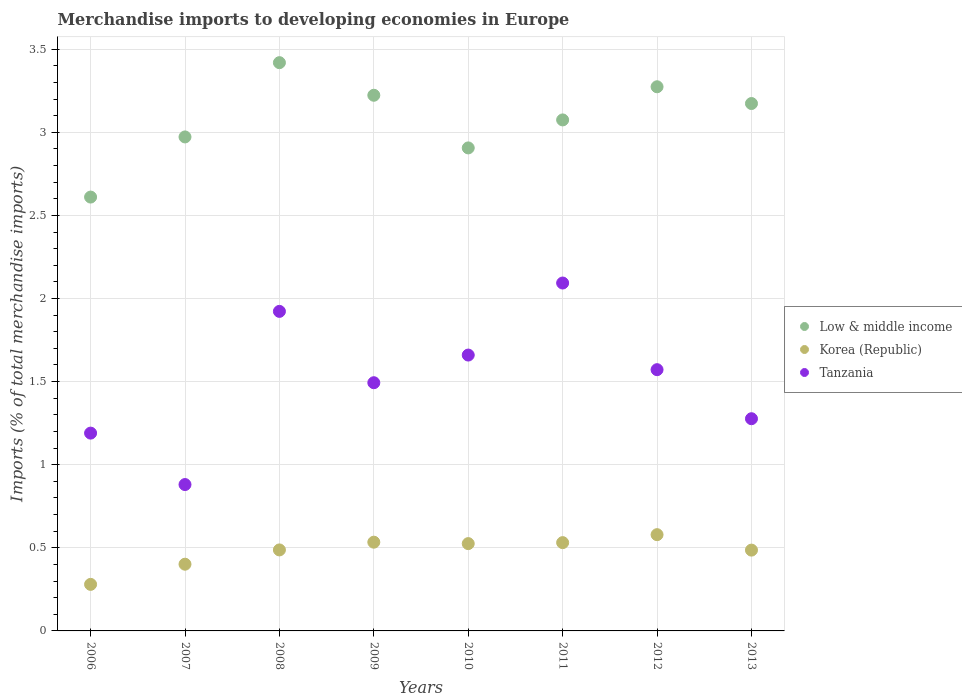How many different coloured dotlines are there?
Provide a short and direct response. 3. Is the number of dotlines equal to the number of legend labels?
Keep it short and to the point. Yes. What is the percentage total merchandise imports in Korea (Republic) in 2007?
Ensure brevity in your answer.  0.4. Across all years, what is the maximum percentage total merchandise imports in Korea (Republic)?
Offer a terse response. 0.58. Across all years, what is the minimum percentage total merchandise imports in Korea (Republic)?
Keep it short and to the point. 0.28. In which year was the percentage total merchandise imports in Low & middle income minimum?
Keep it short and to the point. 2006. What is the total percentage total merchandise imports in Low & middle income in the graph?
Offer a very short reply. 24.65. What is the difference between the percentage total merchandise imports in Tanzania in 2006 and that in 2010?
Ensure brevity in your answer.  -0.47. What is the difference between the percentage total merchandise imports in Tanzania in 2006 and the percentage total merchandise imports in Low & middle income in 2010?
Your answer should be compact. -1.72. What is the average percentage total merchandise imports in Low & middle income per year?
Your response must be concise. 3.08. In the year 2007, what is the difference between the percentage total merchandise imports in Tanzania and percentage total merchandise imports in Korea (Republic)?
Your response must be concise. 0.48. What is the ratio of the percentage total merchandise imports in Tanzania in 2007 to that in 2009?
Provide a succinct answer. 0.59. What is the difference between the highest and the second highest percentage total merchandise imports in Tanzania?
Make the answer very short. 0.17. What is the difference between the highest and the lowest percentage total merchandise imports in Tanzania?
Make the answer very short. 1.21. In how many years, is the percentage total merchandise imports in Tanzania greater than the average percentage total merchandise imports in Tanzania taken over all years?
Make the answer very short. 4. Does the percentage total merchandise imports in Korea (Republic) monotonically increase over the years?
Ensure brevity in your answer.  No. Is the percentage total merchandise imports in Low & middle income strictly greater than the percentage total merchandise imports in Tanzania over the years?
Your response must be concise. Yes. Is the percentage total merchandise imports in Low & middle income strictly less than the percentage total merchandise imports in Korea (Republic) over the years?
Offer a very short reply. No. How many dotlines are there?
Your answer should be compact. 3. How many years are there in the graph?
Provide a short and direct response. 8. Are the values on the major ticks of Y-axis written in scientific E-notation?
Keep it short and to the point. No. Does the graph contain grids?
Offer a terse response. Yes. Where does the legend appear in the graph?
Give a very brief answer. Center right. How many legend labels are there?
Ensure brevity in your answer.  3. How are the legend labels stacked?
Your answer should be compact. Vertical. What is the title of the graph?
Offer a very short reply. Merchandise imports to developing economies in Europe. Does "High income" appear as one of the legend labels in the graph?
Provide a short and direct response. No. What is the label or title of the Y-axis?
Make the answer very short. Imports (% of total merchandise imports). What is the Imports (% of total merchandise imports) of Low & middle income in 2006?
Offer a very short reply. 2.61. What is the Imports (% of total merchandise imports) of Korea (Republic) in 2006?
Your answer should be compact. 0.28. What is the Imports (% of total merchandise imports) of Tanzania in 2006?
Offer a terse response. 1.19. What is the Imports (% of total merchandise imports) of Low & middle income in 2007?
Keep it short and to the point. 2.97. What is the Imports (% of total merchandise imports) in Korea (Republic) in 2007?
Make the answer very short. 0.4. What is the Imports (% of total merchandise imports) of Tanzania in 2007?
Your answer should be very brief. 0.88. What is the Imports (% of total merchandise imports) in Low & middle income in 2008?
Your answer should be very brief. 3.42. What is the Imports (% of total merchandise imports) of Korea (Republic) in 2008?
Your answer should be very brief. 0.49. What is the Imports (% of total merchandise imports) of Tanzania in 2008?
Your answer should be very brief. 1.92. What is the Imports (% of total merchandise imports) in Low & middle income in 2009?
Provide a succinct answer. 3.22. What is the Imports (% of total merchandise imports) in Korea (Republic) in 2009?
Keep it short and to the point. 0.53. What is the Imports (% of total merchandise imports) in Tanzania in 2009?
Ensure brevity in your answer.  1.49. What is the Imports (% of total merchandise imports) of Low & middle income in 2010?
Make the answer very short. 2.91. What is the Imports (% of total merchandise imports) of Korea (Republic) in 2010?
Offer a very short reply. 0.53. What is the Imports (% of total merchandise imports) of Tanzania in 2010?
Offer a very short reply. 1.66. What is the Imports (% of total merchandise imports) of Low & middle income in 2011?
Give a very brief answer. 3.07. What is the Imports (% of total merchandise imports) in Korea (Republic) in 2011?
Offer a terse response. 0.53. What is the Imports (% of total merchandise imports) of Tanzania in 2011?
Keep it short and to the point. 2.09. What is the Imports (% of total merchandise imports) in Low & middle income in 2012?
Keep it short and to the point. 3.27. What is the Imports (% of total merchandise imports) of Korea (Republic) in 2012?
Your response must be concise. 0.58. What is the Imports (% of total merchandise imports) of Tanzania in 2012?
Provide a succinct answer. 1.57. What is the Imports (% of total merchandise imports) of Low & middle income in 2013?
Make the answer very short. 3.17. What is the Imports (% of total merchandise imports) of Korea (Republic) in 2013?
Ensure brevity in your answer.  0.49. What is the Imports (% of total merchandise imports) in Tanzania in 2013?
Make the answer very short. 1.28. Across all years, what is the maximum Imports (% of total merchandise imports) of Low & middle income?
Make the answer very short. 3.42. Across all years, what is the maximum Imports (% of total merchandise imports) of Korea (Republic)?
Offer a terse response. 0.58. Across all years, what is the maximum Imports (% of total merchandise imports) in Tanzania?
Give a very brief answer. 2.09. Across all years, what is the minimum Imports (% of total merchandise imports) in Low & middle income?
Your response must be concise. 2.61. Across all years, what is the minimum Imports (% of total merchandise imports) of Korea (Republic)?
Your answer should be very brief. 0.28. Across all years, what is the minimum Imports (% of total merchandise imports) of Tanzania?
Make the answer very short. 0.88. What is the total Imports (% of total merchandise imports) of Low & middle income in the graph?
Your answer should be very brief. 24.65. What is the total Imports (% of total merchandise imports) in Korea (Republic) in the graph?
Offer a very short reply. 3.82. What is the total Imports (% of total merchandise imports) of Tanzania in the graph?
Offer a terse response. 12.09. What is the difference between the Imports (% of total merchandise imports) in Low & middle income in 2006 and that in 2007?
Provide a short and direct response. -0.36. What is the difference between the Imports (% of total merchandise imports) of Korea (Republic) in 2006 and that in 2007?
Your answer should be very brief. -0.12. What is the difference between the Imports (% of total merchandise imports) in Tanzania in 2006 and that in 2007?
Your answer should be compact. 0.31. What is the difference between the Imports (% of total merchandise imports) in Low & middle income in 2006 and that in 2008?
Give a very brief answer. -0.81. What is the difference between the Imports (% of total merchandise imports) of Korea (Republic) in 2006 and that in 2008?
Provide a short and direct response. -0.21. What is the difference between the Imports (% of total merchandise imports) of Tanzania in 2006 and that in 2008?
Provide a short and direct response. -0.73. What is the difference between the Imports (% of total merchandise imports) of Low & middle income in 2006 and that in 2009?
Offer a very short reply. -0.61. What is the difference between the Imports (% of total merchandise imports) of Korea (Republic) in 2006 and that in 2009?
Your answer should be very brief. -0.25. What is the difference between the Imports (% of total merchandise imports) of Tanzania in 2006 and that in 2009?
Your response must be concise. -0.3. What is the difference between the Imports (% of total merchandise imports) in Low & middle income in 2006 and that in 2010?
Ensure brevity in your answer.  -0.3. What is the difference between the Imports (% of total merchandise imports) in Korea (Republic) in 2006 and that in 2010?
Offer a very short reply. -0.25. What is the difference between the Imports (% of total merchandise imports) of Tanzania in 2006 and that in 2010?
Give a very brief answer. -0.47. What is the difference between the Imports (% of total merchandise imports) in Low & middle income in 2006 and that in 2011?
Ensure brevity in your answer.  -0.46. What is the difference between the Imports (% of total merchandise imports) in Korea (Republic) in 2006 and that in 2011?
Offer a very short reply. -0.25. What is the difference between the Imports (% of total merchandise imports) in Tanzania in 2006 and that in 2011?
Provide a short and direct response. -0.9. What is the difference between the Imports (% of total merchandise imports) of Low & middle income in 2006 and that in 2012?
Provide a succinct answer. -0.66. What is the difference between the Imports (% of total merchandise imports) of Korea (Republic) in 2006 and that in 2012?
Your answer should be compact. -0.3. What is the difference between the Imports (% of total merchandise imports) in Tanzania in 2006 and that in 2012?
Your answer should be very brief. -0.38. What is the difference between the Imports (% of total merchandise imports) of Low & middle income in 2006 and that in 2013?
Provide a succinct answer. -0.56. What is the difference between the Imports (% of total merchandise imports) in Korea (Republic) in 2006 and that in 2013?
Offer a very short reply. -0.21. What is the difference between the Imports (% of total merchandise imports) of Tanzania in 2006 and that in 2013?
Your answer should be very brief. -0.09. What is the difference between the Imports (% of total merchandise imports) of Low & middle income in 2007 and that in 2008?
Offer a very short reply. -0.45. What is the difference between the Imports (% of total merchandise imports) of Korea (Republic) in 2007 and that in 2008?
Provide a succinct answer. -0.09. What is the difference between the Imports (% of total merchandise imports) of Tanzania in 2007 and that in 2008?
Your response must be concise. -1.04. What is the difference between the Imports (% of total merchandise imports) in Low & middle income in 2007 and that in 2009?
Ensure brevity in your answer.  -0.25. What is the difference between the Imports (% of total merchandise imports) in Korea (Republic) in 2007 and that in 2009?
Give a very brief answer. -0.13. What is the difference between the Imports (% of total merchandise imports) in Tanzania in 2007 and that in 2009?
Offer a terse response. -0.61. What is the difference between the Imports (% of total merchandise imports) in Low & middle income in 2007 and that in 2010?
Your response must be concise. 0.07. What is the difference between the Imports (% of total merchandise imports) in Korea (Republic) in 2007 and that in 2010?
Ensure brevity in your answer.  -0.12. What is the difference between the Imports (% of total merchandise imports) in Tanzania in 2007 and that in 2010?
Offer a terse response. -0.78. What is the difference between the Imports (% of total merchandise imports) in Low & middle income in 2007 and that in 2011?
Your answer should be very brief. -0.1. What is the difference between the Imports (% of total merchandise imports) of Korea (Republic) in 2007 and that in 2011?
Offer a very short reply. -0.13. What is the difference between the Imports (% of total merchandise imports) in Tanzania in 2007 and that in 2011?
Offer a terse response. -1.21. What is the difference between the Imports (% of total merchandise imports) in Low & middle income in 2007 and that in 2012?
Ensure brevity in your answer.  -0.3. What is the difference between the Imports (% of total merchandise imports) in Korea (Republic) in 2007 and that in 2012?
Offer a very short reply. -0.18. What is the difference between the Imports (% of total merchandise imports) of Tanzania in 2007 and that in 2012?
Offer a terse response. -0.69. What is the difference between the Imports (% of total merchandise imports) of Low & middle income in 2007 and that in 2013?
Keep it short and to the point. -0.2. What is the difference between the Imports (% of total merchandise imports) of Korea (Republic) in 2007 and that in 2013?
Make the answer very short. -0.08. What is the difference between the Imports (% of total merchandise imports) of Tanzania in 2007 and that in 2013?
Your answer should be very brief. -0.4. What is the difference between the Imports (% of total merchandise imports) of Low & middle income in 2008 and that in 2009?
Provide a succinct answer. 0.2. What is the difference between the Imports (% of total merchandise imports) of Korea (Republic) in 2008 and that in 2009?
Provide a short and direct response. -0.05. What is the difference between the Imports (% of total merchandise imports) in Tanzania in 2008 and that in 2009?
Provide a short and direct response. 0.43. What is the difference between the Imports (% of total merchandise imports) of Low & middle income in 2008 and that in 2010?
Your response must be concise. 0.51. What is the difference between the Imports (% of total merchandise imports) of Korea (Republic) in 2008 and that in 2010?
Keep it short and to the point. -0.04. What is the difference between the Imports (% of total merchandise imports) in Tanzania in 2008 and that in 2010?
Your response must be concise. 0.26. What is the difference between the Imports (% of total merchandise imports) in Low & middle income in 2008 and that in 2011?
Your response must be concise. 0.34. What is the difference between the Imports (% of total merchandise imports) of Korea (Republic) in 2008 and that in 2011?
Keep it short and to the point. -0.04. What is the difference between the Imports (% of total merchandise imports) in Tanzania in 2008 and that in 2011?
Your response must be concise. -0.17. What is the difference between the Imports (% of total merchandise imports) in Low & middle income in 2008 and that in 2012?
Your answer should be compact. 0.14. What is the difference between the Imports (% of total merchandise imports) in Korea (Republic) in 2008 and that in 2012?
Your response must be concise. -0.09. What is the difference between the Imports (% of total merchandise imports) in Tanzania in 2008 and that in 2012?
Offer a very short reply. 0.35. What is the difference between the Imports (% of total merchandise imports) in Low & middle income in 2008 and that in 2013?
Provide a short and direct response. 0.25. What is the difference between the Imports (% of total merchandise imports) of Korea (Republic) in 2008 and that in 2013?
Your response must be concise. 0. What is the difference between the Imports (% of total merchandise imports) in Tanzania in 2008 and that in 2013?
Your answer should be very brief. 0.65. What is the difference between the Imports (% of total merchandise imports) in Low & middle income in 2009 and that in 2010?
Offer a very short reply. 0.32. What is the difference between the Imports (% of total merchandise imports) in Korea (Republic) in 2009 and that in 2010?
Your answer should be very brief. 0.01. What is the difference between the Imports (% of total merchandise imports) in Tanzania in 2009 and that in 2010?
Keep it short and to the point. -0.17. What is the difference between the Imports (% of total merchandise imports) in Low & middle income in 2009 and that in 2011?
Your response must be concise. 0.15. What is the difference between the Imports (% of total merchandise imports) in Korea (Republic) in 2009 and that in 2011?
Make the answer very short. 0. What is the difference between the Imports (% of total merchandise imports) in Tanzania in 2009 and that in 2011?
Give a very brief answer. -0.6. What is the difference between the Imports (% of total merchandise imports) in Low & middle income in 2009 and that in 2012?
Keep it short and to the point. -0.05. What is the difference between the Imports (% of total merchandise imports) in Korea (Republic) in 2009 and that in 2012?
Give a very brief answer. -0.05. What is the difference between the Imports (% of total merchandise imports) of Tanzania in 2009 and that in 2012?
Keep it short and to the point. -0.08. What is the difference between the Imports (% of total merchandise imports) of Low & middle income in 2009 and that in 2013?
Your answer should be very brief. 0.05. What is the difference between the Imports (% of total merchandise imports) of Korea (Republic) in 2009 and that in 2013?
Ensure brevity in your answer.  0.05. What is the difference between the Imports (% of total merchandise imports) of Tanzania in 2009 and that in 2013?
Keep it short and to the point. 0.22. What is the difference between the Imports (% of total merchandise imports) in Low & middle income in 2010 and that in 2011?
Keep it short and to the point. -0.17. What is the difference between the Imports (% of total merchandise imports) in Korea (Republic) in 2010 and that in 2011?
Ensure brevity in your answer.  -0.01. What is the difference between the Imports (% of total merchandise imports) of Tanzania in 2010 and that in 2011?
Keep it short and to the point. -0.43. What is the difference between the Imports (% of total merchandise imports) of Low & middle income in 2010 and that in 2012?
Provide a succinct answer. -0.37. What is the difference between the Imports (% of total merchandise imports) of Korea (Republic) in 2010 and that in 2012?
Offer a terse response. -0.05. What is the difference between the Imports (% of total merchandise imports) in Tanzania in 2010 and that in 2012?
Keep it short and to the point. 0.09. What is the difference between the Imports (% of total merchandise imports) in Low & middle income in 2010 and that in 2013?
Provide a short and direct response. -0.27. What is the difference between the Imports (% of total merchandise imports) in Korea (Republic) in 2010 and that in 2013?
Your answer should be very brief. 0.04. What is the difference between the Imports (% of total merchandise imports) of Tanzania in 2010 and that in 2013?
Your answer should be compact. 0.38. What is the difference between the Imports (% of total merchandise imports) of Low & middle income in 2011 and that in 2012?
Give a very brief answer. -0.2. What is the difference between the Imports (% of total merchandise imports) in Korea (Republic) in 2011 and that in 2012?
Make the answer very short. -0.05. What is the difference between the Imports (% of total merchandise imports) in Tanzania in 2011 and that in 2012?
Offer a terse response. 0.52. What is the difference between the Imports (% of total merchandise imports) of Low & middle income in 2011 and that in 2013?
Make the answer very short. -0.1. What is the difference between the Imports (% of total merchandise imports) of Korea (Republic) in 2011 and that in 2013?
Your answer should be compact. 0.04. What is the difference between the Imports (% of total merchandise imports) in Tanzania in 2011 and that in 2013?
Your answer should be compact. 0.82. What is the difference between the Imports (% of total merchandise imports) of Low & middle income in 2012 and that in 2013?
Your response must be concise. 0.1. What is the difference between the Imports (% of total merchandise imports) of Korea (Republic) in 2012 and that in 2013?
Your answer should be very brief. 0.09. What is the difference between the Imports (% of total merchandise imports) in Tanzania in 2012 and that in 2013?
Your response must be concise. 0.3. What is the difference between the Imports (% of total merchandise imports) in Low & middle income in 2006 and the Imports (% of total merchandise imports) in Korea (Republic) in 2007?
Offer a terse response. 2.21. What is the difference between the Imports (% of total merchandise imports) of Low & middle income in 2006 and the Imports (% of total merchandise imports) of Tanzania in 2007?
Provide a short and direct response. 1.73. What is the difference between the Imports (% of total merchandise imports) in Korea (Republic) in 2006 and the Imports (% of total merchandise imports) in Tanzania in 2007?
Your answer should be compact. -0.6. What is the difference between the Imports (% of total merchandise imports) of Low & middle income in 2006 and the Imports (% of total merchandise imports) of Korea (Republic) in 2008?
Provide a succinct answer. 2.12. What is the difference between the Imports (% of total merchandise imports) of Low & middle income in 2006 and the Imports (% of total merchandise imports) of Tanzania in 2008?
Give a very brief answer. 0.69. What is the difference between the Imports (% of total merchandise imports) in Korea (Republic) in 2006 and the Imports (% of total merchandise imports) in Tanzania in 2008?
Your response must be concise. -1.64. What is the difference between the Imports (% of total merchandise imports) in Low & middle income in 2006 and the Imports (% of total merchandise imports) in Korea (Republic) in 2009?
Keep it short and to the point. 2.08. What is the difference between the Imports (% of total merchandise imports) of Low & middle income in 2006 and the Imports (% of total merchandise imports) of Tanzania in 2009?
Offer a terse response. 1.12. What is the difference between the Imports (% of total merchandise imports) of Korea (Republic) in 2006 and the Imports (% of total merchandise imports) of Tanzania in 2009?
Provide a short and direct response. -1.21. What is the difference between the Imports (% of total merchandise imports) in Low & middle income in 2006 and the Imports (% of total merchandise imports) in Korea (Republic) in 2010?
Give a very brief answer. 2.08. What is the difference between the Imports (% of total merchandise imports) of Low & middle income in 2006 and the Imports (% of total merchandise imports) of Tanzania in 2010?
Keep it short and to the point. 0.95. What is the difference between the Imports (% of total merchandise imports) in Korea (Republic) in 2006 and the Imports (% of total merchandise imports) in Tanzania in 2010?
Your answer should be very brief. -1.38. What is the difference between the Imports (% of total merchandise imports) of Low & middle income in 2006 and the Imports (% of total merchandise imports) of Korea (Republic) in 2011?
Your answer should be compact. 2.08. What is the difference between the Imports (% of total merchandise imports) in Low & middle income in 2006 and the Imports (% of total merchandise imports) in Tanzania in 2011?
Keep it short and to the point. 0.52. What is the difference between the Imports (% of total merchandise imports) of Korea (Republic) in 2006 and the Imports (% of total merchandise imports) of Tanzania in 2011?
Provide a short and direct response. -1.81. What is the difference between the Imports (% of total merchandise imports) of Low & middle income in 2006 and the Imports (% of total merchandise imports) of Korea (Republic) in 2012?
Offer a very short reply. 2.03. What is the difference between the Imports (% of total merchandise imports) in Low & middle income in 2006 and the Imports (% of total merchandise imports) in Tanzania in 2012?
Keep it short and to the point. 1.04. What is the difference between the Imports (% of total merchandise imports) in Korea (Republic) in 2006 and the Imports (% of total merchandise imports) in Tanzania in 2012?
Your answer should be compact. -1.29. What is the difference between the Imports (% of total merchandise imports) in Low & middle income in 2006 and the Imports (% of total merchandise imports) in Korea (Republic) in 2013?
Offer a very short reply. 2.12. What is the difference between the Imports (% of total merchandise imports) of Low & middle income in 2006 and the Imports (% of total merchandise imports) of Tanzania in 2013?
Make the answer very short. 1.33. What is the difference between the Imports (% of total merchandise imports) of Korea (Republic) in 2006 and the Imports (% of total merchandise imports) of Tanzania in 2013?
Offer a very short reply. -1. What is the difference between the Imports (% of total merchandise imports) of Low & middle income in 2007 and the Imports (% of total merchandise imports) of Korea (Republic) in 2008?
Make the answer very short. 2.48. What is the difference between the Imports (% of total merchandise imports) of Low & middle income in 2007 and the Imports (% of total merchandise imports) of Tanzania in 2008?
Keep it short and to the point. 1.05. What is the difference between the Imports (% of total merchandise imports) of Korea (Republic) in 2007 and the Imports (% of total merchandise imports) of Tanzania in 2008?
Offer a very short reply. -1.52. What is the difference between the Imports (% of total merchandise imports) of Low & middle income in 2007 and the Imports (% of total merchandise imports) of Korea (Republic) in 2009?
Offer a terse response. 2.44. What is the difference between the Imports (% of total merchandise imports) in Low & middle income in 2007 and the Imports (% of total merchandise imports) in Tanzania in 2009?
Offer a very short reply. 1.48. What is the difference between the Imports (% of total merchandise imports) of Korea (Republic) in 2007 and the Imports (% of total merchandise imports) of Tanzania in 2009?
Your answer should be very brief. -1.09. What is the difference between the Imports (% of total merchandise imports) of Low & middle income in 2007 and the Imports (% of total merchandise imports) of Korea (Republic) in 2010?
Give a very brief answer. 2.45. What is the difference between the Imports (% of total merchandise imports) of Low & middle income in 2007 and the Imports (% of total merchandise imports) of Tanzania in 2010?
Keep it short and to the point. 1.31. What is the difference between the Imports (% of total merchandise imports) in Korea (Republic) in 2007 and the Imports (% of total merchandise imports) in Tanzania in 2010?
Offer a terse response. -1.26. What is the difference between the Imports (% of total merchandise imports) of Low & middle income in 2007 and the Imports (% of total merchandise imports) of Korea (Republic) in 2011?
Your response must be concise. 2.44. What is the difference between the Imports (% of total merchandise imports) of Low & middle income in 2007 and the Imports (% of total merchandise imports) of Tanzania in 2011?
Keep it short and to the point. 0.88. What is the difference between the Imports (% of total merchandise imports) in Korea (Republic) in 2007 and the Imports (% of total merchandise imports) in Tanzania in 2011?
Give a very brief answer. -1.69. What is the difference between the Imports (% of total merchandise imports) in Low & middle income in 2007 and the Imports (% of total merchandise imports) in Korea (Republic) in 2012?
Ensure brevity in your answer.  2.39. What is the difference between the Imports (% of total merchandise imports) of Low & middle income in 2007 and the Imports (% of total merchandise imports) of Tanzania in 2012?
Your answer should be very brief. 1.4. What is the difference between the Imports (% of total merchandise imports) of Korea (Republic) in 2007 and the Imports (% of total merchandise imports) of Tanzania in 2012?
Provide a short and direct response. -1.17. What is the difference between the Imports (% of total merchandise imports) of Low & middle income in 2007 and the Imports (% of total merchandise imports) of Korea (Republic) in 2013?
Offer a terse response. 2.49. What is the difference between the Imports (% of total merchandise imports) of Low & middle income in 2007 and the Imports (% of total merchandise imports) of Tanzania in 2013?
Ensure brevity in your answer.  1.7. What is the difference between the Imports (% of total merchandise imports) of Korea (Republic) in 2007 and the Imports (% of total merchandise imports) of Tanzania in 2013?
Give a very brief answer. -0.88. What is the difference between the Imports (% of total merchandise imports) of Low & middle income in 2008 and the Imports (% of total merchandise imports) of Korea (Republic) in 2009?
Your response must be concise. 2.88. What is the difference between the Imports (% of total merchandise imports) in Low & middle income in 2008 and the Imports (% of total merchandise imports) in Tanzania in 2009?
Give a very brief answer. 1.93. What is the difference between the Imports (% of total merchandise imports) of Korea (Republic) in 2008 and the Imports (% of total merchandise imports) of Tanzania in 2009?
Offer a very short reply. -1.01. What is the difference between the Imports (% of total merchandise imports) in Low & middle income in 2008 and the Imports (% of total merchandise imports) in Korea (Republic) in 2010?
Your answer should be compact. 2.89. What is the difference between the Imports (% of total merchandise imports) in Low & middle income in 2008 and the Imports (% of total merchandise imports) in Tanzania in 2010?
Your answer should be very brief. 1.76. What is the difference between the Imports (% of total merchandise imports) in Korea (Republic) in 2008 and the Imports (% of total merchandise imports) in Tanzania in 2010?
Ensure brevity in your answer.  -1.17. What is the difference between the Imports (% of total merchandise imports) in Low & middle income in 2008 and the Imports (% of total merchandise imports) in Korea (Republic) in 2011?
Your response must be concise. 2.89. What is the difference between the Imports (% of total merchandise imports) of Low & middle income in 2008 and the Imports (% of total merchandise imports) of Tanzania in 2011?
Give a very brief answer. 1.33. What is the difference between the Imports (% of total merchandise imports) of Korea (Republic) in 2008 and the Imports (% of total merchandise imports) of Tanzania in 2011?
Your response must be concise. -1.61. What is the difference between the Imports (% of total merchandise imports) of Low & middle income in 2008 and the Imports (% of total merchandise imports) of Korea (Republic) in 2012?
Provide a succinct answer. 2.84. What is the difference between the Imports (% of total merchandise imports) of Low & middle income in 2008 and the Imports (% of total merchandise imports) of Tanzania in 2012?
Provide a succinct answer. 1.85. What is the difference between the Imports (% of total merchandise imports) in Korea (Republic) in 2008 and the Imports (% of total merchandise imports) in Tanzania in 2012?
Provide a succinct answer. -1.08. What is the difference between the Imports (% of total merchandise imports) of Low & middle income in 2008 and the Imports (% of total merchandise imports) of Korea (Republic) in 2013?
Offer a terse response. 2.93. What is the difference between the Imports (% of total merchandise imports) in Low & middle income in 2008 and the Imports (% of total merchandise imports) in Tanzania in 2013?
Offer a terse response. 2.14. What is the difference between the Imports (% of total merchandise imports) of Korea (Republic) in 2008 and the Imports (% of total merchandise imports) of Tanzania in 2013?
Offer a very short reply. -0.79. What is the difference between the Imports (% of total merchandise imports) in Low & middle income in 2009 and the Imports (% of total merchandise imports) in Korea (Republic) in 2010?
Provide a short and direct response. 2.7. What is the difference between the Imports (% of total merchandise imports) in Low & middle income in 2009 and the Imports (% of total merchandise imports) in Tanzania in 2010?
Your response must be concise. 1.56. What is the difference between the Imports (% of total merchandise imports) of Korea (Republic) in 2009 and the Imports (% of total merchandise imports) of Tanzania in 2010?
Your answer should be very brief. -1.13. What is the difference between the Imports (% of total merchandise imports) of Low & middle income in 2009 and the Imports (% of total merchandise imports) of Korea (Republic) in 2011?
Offer a terse response. 2.69. What is the difference between the Imports (% of total merchandise imports) in Low & middle income in 2009 and the Imports (% of total merchandise imports) in Tanzania in 2011?
Ensure brevity in your answer.  1.13. What is the difference between the Imports (% of total merchandise imports) of Korea (Republic) in 2009 and the Imports (% of total merchandise imports) of Tanzania in 2011?
Make the answer very short. -1.56. What is the difference between the Imports (% of total merchandise imports) of Low & middle income in 2009 and the Imports (% of total merchandise imports) of Korea (Republic) in 2012?
Provide a succinct answer. 2.64. What is the difference between the Imports (% of total merchandise imports) of Low & middle income in 2009 and the Imports (% of total merchandise imports) of Tanzania in 2012?
Your answer should be compact. 1.65. What is the difference between the Imports (% of total merchandise imports) of Korea (Republic) in 2009 and the Imports (% of total merchandise imports) of Tanzania in 2012?
Provide a succinct answer. -1.04. What is the difference between the Imports (% of total merchandise imports) of Low & middle income in 2009 and the Imports (% of total merchandise imports) of Korea (Republic) in 2013?
Ensure brevity in your answer.  2.74. What is the difference between the Imports (% of total merchandise imports) in Low & middle income in 2009 and the Imports (% of total merchandise imports) in Tanzania in 2013?
Provide a short and direct response. 1.95. What is the difference between the Imports (% of total merchandise imports) of Korea (Republic) in 2009 and the Imports (% of total merchandise imports) of Tanzania in 2013?
Keep it short and to the point. -0.74. What is the difference between the Imports (% of total merchandise imports) of Low & middle income in 2010 and the Imports (% of total merchandise imports) of Korea (Republic) in 2011?
Ensure brevity in your answer.  2.37. What is the difference between the Imports (% of total merchandise imports) of Low & middle income in 2010 and the Imports (% of total merchandise imports) of Tanzania in 2011?
Your response must be concise. 0.81. What is the difference between the Imports (% of total merchandise imports) of Korea (Republic) in 2010 and the Imports (% of total merchandise imports) of Tanzania in 2011?
Your response must be concise. -1.57. What is the difference between the Imports (% of total merchandise imports) of Low & middle income in 2010 and the Imports (% of total merchandise imports) of Korea (Republic) in 2012?
Give a very brief answer. 2.33. What is the difference between the Imports (% of total merchandise imports) in Low & middle income in 2010 and the Imports (% of total merchandise imports) in Tanzania in 2012?
Ensure brevity in your answer.  1.33. What is the difference between the Imports (% of total merchandise imports) in Korea (Republic) in 2010 and the Imports (% of total merchandise imports) in Tanzania in 2012?
Make the answer very short. -1.05. What is the difference between the Imports (% of total merchandise imports) of Low & middle income in 2010 and the Imports (% of total merchandise imports) of Korea (Republic) in 2013?
Offer a very short reply. 2.42. What is the difference between the Imports (% of total merchandise imports) in Low & middle income in 2010 and the Imports (% of total merchandise imports) in Tanzania in 2013?
Keep it short and to the point. 1.63. What is the difference between the Imports (% of total merchandise imports) in Korea (Republic) in 2010 and the Imports (% of total merchandise imports) in Tanzania in 2013?
Provide a succinct answer. -0.75. What is the difference between the Imports (% of total merchandise imports) in Low & middle income in 2011 and the Imports (% of total merchandise imports) in Korea (Republic) in 2012?
Provide a short and direct response. 2.5. What is the difference between the Imports (% of total merchandise imports) in Low & middle income in 2011 and the Imports (% of total merchandise imports) in Tanzania in 2012?
Your answer should be very brief. 1.5. What is the difference between the Imports (% of total merchandise imports) in Korea (Republic) in 2011 and the Imports (% of total merchandise imports) in Tanzania in 2012?
Your response must be concise. -1.04. What is the difference between the Imports (% of total merchandise imports) in Low & middle income in 2011 and the Imports (% of total merchandise imports) in Korea (Republic) in 2013?
Keep it short and to the point. 2.59. What is the difference between the Imports (% of total merchandise imports) of Low & middle income in 2011 and the Imports (% of total merchandise imports) of Tanzania in 2013?
Your answer should be compact. 1.8. What is the difference between the Imports (% of total merchandise imports) of Korea (Republic) in 2011 and the Imports (% of total merchandise imports) of Tanzania in 2013?
Offer a terse response. -0.75. What is the difference between the Imports (% of total merchandise imports) of Low & middle income in 2012 and the Imports (% of total merchandise imports) of Korea (Republic) in 2013?
Offer a terse response. 2.79. What is the difference between the Imports (% of total merchandise imports) of Low & middle income in 2012 and the Imports (% of total merchandise imports) of Tanzania in 2013?
Ensure brevity in your answer.  2. What is the difference between the Imports (% of total merchandise imports) of Korea (Republic) in 2012 and the Imports (% of total merchandise imports) of Tanzania in 2013?
Keep it short and to the point. -0.7. What is the average Imports (% of total merchandise imports) in Low & middle income per year?
Make the answer very short. 3.08. What is the average Imports (% of total merchandise imports) of Korea (Republic) per year?
Ensure brevity in your answer.  0.48. What is the average Imports (% of total merchandise imports) in Tanzania per year?
Ensure brevity in your answer.  1.51. In the year 2006, what is the difference between the Imports (% of total merchandise imports) in Low & middle income and Imports (% of total merchandise imports) in Korea (Republic)?
Provide a succinct answer. 2.33. In the year 2006, what is the difference between the Imports (% of total merchandise imports) in Low & middle income and Imports (% of total merchandise imports) in Tanzania?
Ensure brevity in your answer.  1.42. In the year 2006, what is the difference between the Imports (% of total merchandise imports) of Korea (Republic) and Imports (% of total merchandise imports) of Tanzania?
Your answer should be compact. -0.91. In the year 2007, what is the difference between the Imports (% of total merchandise imports) in Low & middle income and Imports (% of total merchandise imports) in Korea (Republic)?
Keep it short and to the point. 2.57. In the year 2007, what is the difference between the Imports (% of total merchandise imports) of Low & middle income and Imports (% of total merchandise imports) of Tanzania?
Give a very brief answer. 2.09. In the year 2007, what is the difference between the Imports (% of total merchandise imports) of Korea (Republic) and Imports (% of total merchandise imports) of Tanzania?
Give a very brief answer. -0.48. In the year 2008, what is the difference between the Imports (% of total merchandise imports) in Low & middle income and Imports (% of total merchandise imports) in Korea (Republic)?
Offer a terse response. 2.93. In the year 2008, what is the difference between the Imports (% of total merchandise imports) in Low & middle income and Imports (% of total merchandise imports) in Tanzania?
Provide a short and direct response. 1.5. In the year 2008, what is the difference between the Imports (% of total merchandise imports) of Korea (Republic) and Imports (% of total merchandise imports) of Tanzania?
Ensure brevity in your answer.  -1.44. In the year 2009, what is the difference between the Imports (% of total merchandise imports) of Low & middle income and Imports (% of total merchandise imports) of Korea (Republic)?
Your answer should be very brief. 2.69. In the year 2009, what is the difference between the Imports (% of total merchandise imports) of Low & middle income and Imports (% of total merchandise imports) of Tanzania?
Keep it short and to the point. 1.73. In the year 2009, what is the difference between the Imports (% of total merchandise imports) in Korea (Republic) and Imports (% of total merchandise imports) in Tanzania?
Ensure brevity in your answer.  -0.96. In the year 2010, what is the difference between the Imports (% of total merchandise imports) in Low & middle income and Imports (% of total merchandise imports) in Korea (Republic)?
Offer a terse response. 2.38. In the year 2010, what is the difference between the Imports (% of total merchandise imports) in Low & middle income and Imports (% of total merchandise imports) in Tanzania?
Provide a succinct answer. 1.25. In the year 2010, what is the difference between the Imports (% of total merchandise imports) in Korea (Republic) and Imports (% of total merchandise imports) in Tanzania?
Your answer should be very brief. -1.13. In the year 2011, what is the difference between the Imports (% of total merchandise imports) in Low & middle income and Imports (% of total merchandise imports) in Korea (Republic)?
Give a very brief answer. 2.54. In the year 2011, what is the difference between the Imports (% of total merchandise imports) of Low & middle income and Imports (% of total merchandise imports) of Tanzania?
Ensure brevity in your answer.  0.98. In the year 2011, what is the difference between the Imports (% of total merchandise imports) of Korea (Republic) and Imports (% of total merchandise imports) of Tanzania?
Offer a very short reply. -1.56. In the year 2012, what is the difference between the Imports (% of total merchandise imports) in Low & middle income and Imports (% of total merchandise imports) in Korea (Republic)?
Make the answer very short. 2.69. In the year 2012, what is the difference between the Imports (% of total merchandise imports) in Low & middle income and Imports (% of total merchandise imports) in Tanzania?
Offer a very short reply. 1.7. In the year 2012, what is the difference between the Imports (% of total merchandise imports) of Korea (Republic) and Imports (% of total merchandise imports) of Tanzania?
Offer a terse response. -0.99. In the year 2013, what is the difference between the Imports (% of total merchandise imports) in Low & middle income and Imports (% of total merchandise imports) in Korea (Republic)?
Offer a terse response. 2.69. In the year 2013, what is the difference between the Imports (% of total merchandise imports) of Low & middle income and Imports (% of total merchandise imports) of Tanzania?
Your answer should be compact. 1.9. In the year 2013, what is the difference between the Imports (% of total merchandise imports) in Korea (Republic) and Imports (% of total merchandise imports) in Tanzania?
Provide a short and direct response. -0.79. What is the ratio of the Imports (% of total merchandise imports) of Low & middle income in 2006 to that in 2007?
Your answer should be very brief. 0.88. What is the ratio of the Imports (% of total merchandise imports) in Korea (Republic) in 2006 to that in 2007?
Give a very brief answer. 0.7. What is the ratio of the Imports (% of total merchandise imports) in Tanzania in 2006 to that in 2007?
Your response must be concise. 1.35. What is the ratio of the Imports (% of total merchandise imports) of Low & middle income in 2006 to that in 2008?
Provide a short and direct response. 0.76. What is the ratio of the Imports (% of total merchandise imports) of Korea (Republic) in 2006 to that in 2008?
Provide a succinct answer. 0.57. What is the ratio of the Imports (% of total merchandise imports) of Tanzania in 2006 to that in 2008?
Ensure brevity in your answer.  0.62. What is the ratio of the Imports (% of total merchandise imports) of Low & middle income in 2006 to that in 2009?
Provide a succinct answer. 0.81. What is the ratio of the Imports (% of total merchandise imports) in Korea (Republic) in 2006 to that in 2009?
Your response must be concise. 0.52. What is the ratio of the Imports (% of total merchandise imports) in Tanzania in 2006 to that in 2009?
Provide a short and direct response. 0.8. What is the ratio of the Imports (% of total merchandise imports) of Low & middle income in 2006 to that in 2010?
Make the answer very short. 0.9. What is the ratio of the Imports (% of total merchandise imports) in Korea (Republic) in 2006 to that in 2010?
Offer a very short reply. 0.53. What is the ratio of the Imports (% of total merchandise imports) in Tanzania in 2006 to that in 2010?
Make the answer very short. 0.72. What is the ratio of the Imports (% of total merchandise imports) in Low & middle income in 2006 to that in 2011?
Your answer should be very brief. 0.85. What is the ratio of the Imports (% of total merchandise imports) of Korea (Republic) in 2006 to that in 2011?
Keep it short and to the point. 0.53. What is the ratio of the Imports (% of total merchandise imports) of Tanzania in 2006 to that in 2011?
Offer a very short reply. 0.57. What is the ratio of the Imports (% of total merchandise imports) of Low & middle income in 2006 to that in 2012?
Make the answer very short. 0.8. What is the ratio of the Imports (% of total merchandise imports) in Korea (Republic) in 2006 to that in 2012?
Keep it short and to the point. 0.48. What is the ratio of the Imports (% of total merchandise imports) of Tanzania in 2006 to that in 2012?
Give a very brief answer. 0.76. What is the ratio of the Imports (% of total merchandise imports) of Low & middle income in 2006 to that in 2013?
Your answer should be very brief. 0.82. What is the ratio of the Imports (% of total merchandise imports) in Korea (Republic) in 2006 to that in 2013?
Provide a short and direct response. 0.58. What is the ratio of the Imports (% of total merchandise imports) in Tanzania in 2006 to that in 2013?
Your response must be concise. 0.93. What is the ratio of the Imports (% of total merchandise imports) of Low & middle income in 2007 to that in 2008?
Keep it short and to the point. 0.87. What is the ratio of the Imports (% of total merchandise imports) of Korea (Republic) in 2007 to that in 2008?
Your response must be concise. 0.82. What is the ratio of the Imports (% of total merchandise imports) of Tanzania in 2007 to that in 2008?
Ensure brevity in your answer.  0.46. What is the ratio of the Imports (% of total merchandise imports) of Low & middle income in 2007 to that in 2009?
Ensure brevity in your answer.  0.92. What is the ratio of the Imports (% of total merchandise imports) of Korea (Republic) in 2007 to that in 2009?
Your answer should be compact. 0.75. What is the ratio of the Imports (% of total merchandise imports) in Tanzania in 2007 to that in 2009?
Ensure brevity in your answer.  0.59. What is the ratio of the Imports (% of total merchandise imports) in Low & middle income in 2007 to that in 2010?
Offer a very short reply. 1.02. What is the ratio of the Imports (% of total merchandise imports) of Korea (Republic) in 2007 to that in 2010?
Your answer should be compact. 0.76. What is the ratio of the Imports (% of total merchandise imports) in Tanzania in 2007 to that in 2010?
Make the answer very short. 0.53. What is the ratio of the Imports (% of total merchandise imports) in Low & middle income in 2007 to that in 2011?
Your response must be concise. 0.97. What is the ratio of the Imports (% of total merchandise imports) of Korea (Republic) in 2007 to that in 2011?
Your answer should be compact. 0.76. What is the ratio of the Imports (% of total merchandise imports) of Tanzania in 2007 to that in 2011?
Offer a terse response. 0.42. What is the ratio of the Imports (% of total merchandise imports) in Low & middle income in 2007 to that in 2012?
Your answer should be very brief. 0.91. What is the ratio of the Imports (% of total merchandise imports) in Korea (Republic) in 2007 to that in 2012?
Give a very brief answer. 0.69. What is the ratio of the Imports (% of total merchandise imports) of Tanzania in 2007 to that in 2012?
Provide a succinct answer. 0.56. What is the ratio of the Imports (% of total merchandise imports) of Low & middle income in 2007 to that in 2013?
Your response must be concise. 0.94. What is the ratio of the Imports (% of total merchandise imports) of Korea (Republic) in 2007 to that in 2013?
Make the answer very short. 0.83. What is the ratio of the Imports (% of total merchandise imports) in Tanzania in 2007 to that in 2013?
Provide a succinct answer. 0.69. What is the ratio of the Imports (% of total merchandise imports) in Low & middle income in 2008 to that in 2009?
Give a very brief answer. 1.06. What is the ratio of the Imports (% of total merchandise imports) in Korea (Republic) in 2008 to that in 2009?
Your answer should be compact. 0.91. What is the ratio of the Imports (% of total merchandise imports) of Tanzania in 2008 to that in 2009?
Offer a terse response. 1.29. What is the ratio of the Imports (% of total merchandise imports) in Low & middle income in 2008 to that in 2010?
Provide a succinct answer. 1.18. What is the ratio of the Imports (% of total merchandise imports) in Korea (Republic) in 2008 to that in 2010?
Make the answer very short. 0.93. What is the ratio of the Imports (% of total merchandise imports) in Tanzania in 2008 to that in 2010?
Provide a succinct answer. 1.16. What is the ratio of the Imports (% of total merchandise imports) in Low & middle income in 2008 to that in 2011?
Give a very brief answer. 1.11. What is the ratio of the Imports (% of total merchandise imports) of Korea (Republic) in 2008 to that in 2011?
Your answer should be very brief. 0.92. What is the ratio of the Imports (% of total merchandise imports) in Tanzania in 2008 to that in 2011?
Provide a short and direct response. 0.92. What is the ratio of the Imports (% of total merchandise imports) in Low & middle income in 2008 to that in 2012?
Offer a very short reply. 1.04. What is the ratio of the Imports (% of total merchandise imports) in Korea (Republic) in 2008 to that in 2012?
Provide a succinct answer. 0.84. What is the ratio of the Imports (% of total merchandise imports) of Tanzania in 2008 to that in 2012?
Your response must be concise. 1.22. What is the ratio of the Imports (% of total merchandise imports) in Low & middle income in 2008 to that in 2013?
Ensure brevity in your answer.  1.08. What is the ratio of the Imports (% of total merchandise imports) of Tanzania in 2008 to that in 2013?
Keep it short and to the point. 1.51. What is the ratio of the Imports (% of total merchandise imports) in Low & middle income in 2009 to that in 2010?
Your response must be concise. 1.11. What is the ratio of the Imports (% of total merchandise imports) in Korea (Republic) in 2009 to that in 2010?
Provide a short and direct response. 1.02. What is the ratio of the Imports (% of total merchandise imports) in Tanzania in 2009 to that in 2010?
Offer a very short reply. 0.9. What is the ratio of the Imports (% of total merchandise imports) in Low & middle income in 2009 to that in 2011?
Offer a very short reply. 1.05. What is the ratio of the Imports (% of total merchandise imports) of Korea (Republic) in 2009 to that in 2011?
Make the answer very short. 1.01. What is the ratio of the Imports (% of total merchandise imports) of Tanzania in 2009 to that in 2011?
Your answer should be compact. 0.71. What is the ratio of the Imports (% of total merchandise imports) in Low & middle income in 2009 to that in 2012?
Make the answer very short. 0.98. What is the ratio of the Imports (% of total merchandise imports) of Korea (Republic) in 2009 to that in 2012?
Your answer should be compact. 0.92. What is the ratio of the Imports (% of total merchandise imports) in Tanzania in 2009 to that in 2012?
Give a very brief answer. 0.95. What is the ratio of the Imports (% of total merchandise imports) of Low & middle income in 2009 to that in 2013?
Provide a short and direct response. 1.02. What is the ratio of the Imports (% of total merchandise imports) in Korea (Republic) in 2009 to that in 2013?
Your answer should be very brief. 1.1. What is the ratio of the Imports (% of total merchandise imports) in Tanzania in 2009 to that in 2013?
Offer a terse response. 1.17. What is the ratio of the Imports (% of total merchandise imports) of Low & middle income in 2010 to that in 2011?
Your answer should be very brief. 0.95. What is the ratio of the Imports (% of total merchandise imports) in Tanzania in 2010 to that in 2011?
Give a very brief answer. 0.79. What is the ratio of the Imports (% of total merchandise imports) of Low & middle income in 2010 to that in 2012?
Your response must be concise. 0.89. What is the ratio of the Imports (% of total merchandise imports) of Korea (Republic) in 2010 to that in 2012?
Your response must be concise. 0.91. What is the ratio of the Imports (% of total merchandise imports) of Tanzania in 2010 to that in 2012?
Provide a short and direct response. 1.06. What is the ratio of the Imports (% of total merchandise imports) in Low & middle income in 2010 to that in 2013?
Your answer should be very brief. 0.92. What is the ratio of the Imports (% of total merchandise imports) of Korea (Republic) in 2010 to that in 2013?
Provide a short and direct response. 1.08. What is the ratio of the Imports (% of total merchandise imports) of Tanzania in 2010 to that in 2013?
Provide a short and direct response. 1.3. What is the ratio of the Imports (% of total merchandise imports) in Low & middle income in 2011 to that in 2012?
Offer a very short reply. 0.94. What is the ratio of the Imports (% of total merchandise imports) in Korea (Republic) in 2011 to that in 2012?
Ensure brevity in your answer.  0.92. What is the ratio of the Imports (% of total merchandise imports) of Tanzania in 2011 to that in 2012?
Make the answer very short. 1.33. What is the ratio of the Imports (% of total merchandise imports) in Low & middle income in 2011 to that in 2013?
Make the answer very short. 0.97. What is the ratio of the Imports (% of total merchandise imports) of Korea (Republic) in 2011 to that in 2013?
Provide a succinct answer. 1.09. What is the ratio of the Imports (% of total merchandise imports) of Tanzania in 2011 to that in 2013?
Provide a short and direct response. 1.64. What is the ratio of the Imports (% of total merchandise imports) in Low & middle income in 2012 to that in 2013?
Ensure brevity in your answer.  1.03. What is the ratio of the Imports (% of total merchandise imports) of Korea (Republic) in 2012 to that in 2013?
Offer a terse response. 1.19. What is the ratio of the Imports (% of total merchandise imports) of Tanzania in 2012 to that in 2013?
Provide a short and direct response. 1.23. What is the difference between the highest and the second highest Imports (% of total merchandise imports) of Low & middle income?
Offer a terse response. 0.14. What is the difference between the highest and the second highest Imports (% of total merchandise imports) of Korea (Republic)?
Offer a terse response. 0.05. What is the difference between the highest and the second highest Imports (% of total merchandise imports) of Tanzania?
Provide a succinct answer. 0.17. What is the difference between the highest and the lowest Imports (% of total merchandise imports) in Low & middle income?
Provide a succinct answer. 0.81. What is the difference between the highest and the lowest Imports (% of total merchandise imports) of Korea (Republic)?
Give a very brief answer. 0.3. What is the difference between the highest and the lowest Imports (% of total merchandise imports) in Tanzania?
Offer a very short reply. 1.21. 